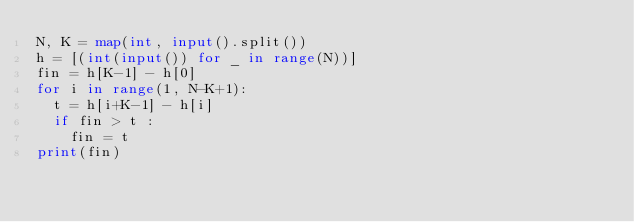Convert code to text. <code><loc_0><loc_0><loc_500><loc_500><_Python_>N, K = map(int, input().split())
h = [(int(input()) for _ in range(N))]
fin = h[K-1] - h[0]
for i in range(1, N-K+1):
  t = h[i+K-1] - h[i]
  if fin > t :
    fin = t
print(fin)
</code> 